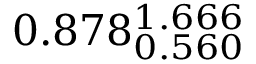Convert formula to latex. <formula><loc_0><loc_0><loc_500><loc_500>0 . 8 7 8 _ { 0 . 5 6 0 } ^ { 1 . 6 6 6 }</formula> 